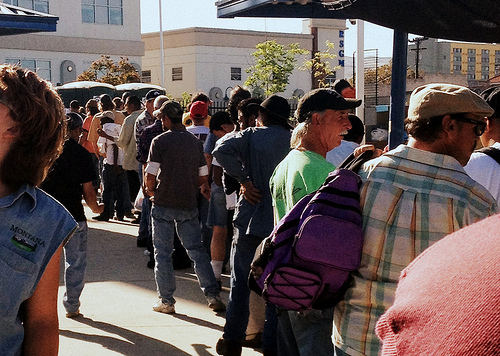<image>
Is the hat on the man? No. The hat is not positioned on the man. They may be near each other, but the hat is not supported by or resting on top of the man. 